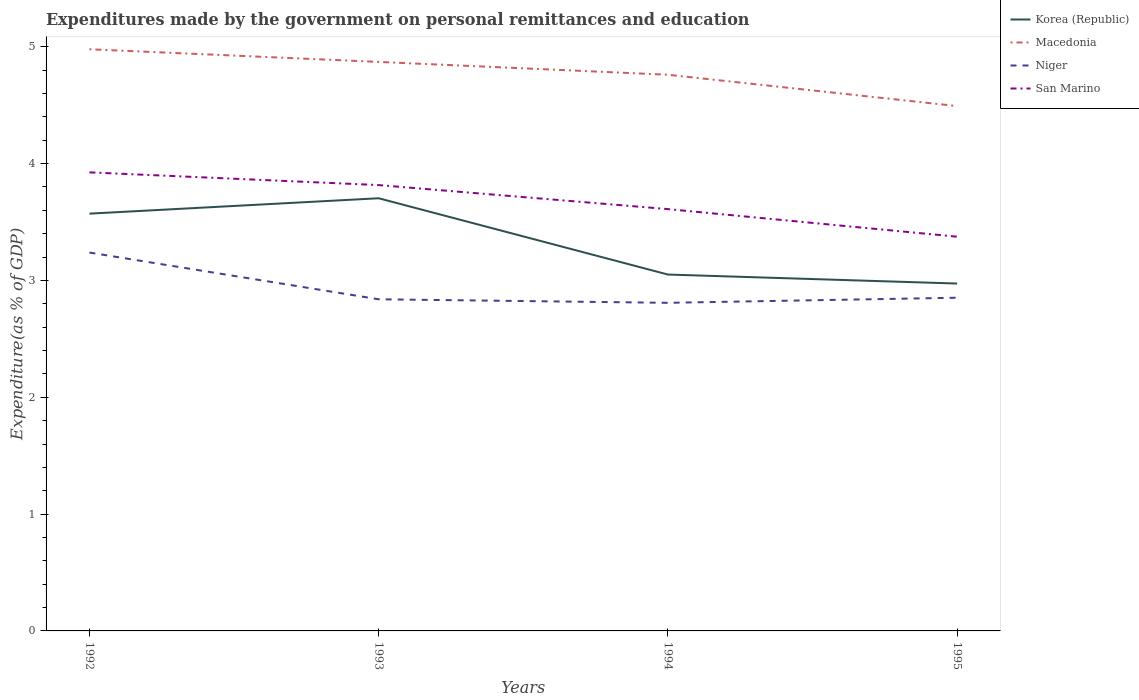Does the line corresponding to Niger intersect with the line corresponding to Macedonia?
Provide a succinct answer. No. Across all years, what is the maximum expenditures made by the government on personal remittances and education in Macedonia?
Your answer should be compact. 4.49. What is the total expenditures made by the government on personal remittances and education in San Marino in the graph?
Your answer should be compact. 0.21. What is the difference between the highest and the second highest expenditures made by the government on personal remittances and education in Korea (Republic)?
Your answer should be compact. 0.73. What is the difference between the highest and the lowest expenditures made by the government on personal remittances and education in Niger?
Make the answer very short. 1. How many years are there in the graph?
Your answer should be very brief. 4. What is the difference between two consecutive major ticks on the Y-axis?
Your answer should be very brief. 1. Does the graph contain any zero values?
Offer a terse response. No. Does the graph contain grids?
Your answer should be very brief. No. How are the legend labels stacked?
Your answer should be compact. Vertical. What is the title of the graph?
Provide a short and direct response. Expenditures made by the government on personal remittances and education. What is the label or title of the X-axis?
Your response must be concise. Years. What is the label or title of the Y-axis?
Provide a succinct answer. Expenditure(as % of GDP). What is the Expenditure(as % of GDP) in Korea (Republic) in 1992?
Provide a succinct answer. 3.57. What is the Expenditure(as % of GDP) of Macedonia in 1992?
Offer a very short reply. 4.98. What is the Expenditure(as % of GDP) in Niger in 1992?
Keep it short and to the point. 3.24. What is the Expenditure(as % of GDP) in San Marino in 1992?
Your answer should be very brief. 3.93. What is the Expenditure(as % of GDP) in Korea (Republic) in 1993?
Offer a terse response. 3.7. What is the Expenditure(as % of GDP) of Macedonia in 1993?
Keep it short and to the point. 4.87. What is the Expenditure(as % of GDP) of Niger in 1993?
Offer a very short reply. 2.84. What is the Expenditure(as % of GDP) of San Marino in 1993?
Give a very brief answer. 3.82. What is the Expenditure(as % of GDP) in Korea (Republic) in 1994?
Ensure brevity in your answer.  3.05. What is the Expenditure(as % of GDP) of Macedonia in 1994?
Provide a short and direct response. 4.76. What is the Expenditure(as % of GDP) in Niger in 1994?
Keep it short and to the point. 2.81. What is the Expenditure(as % of GDP) in San Marino in 1994?
Provide a short and direct response. 3.61. What is the Expenditure(as % of GDP) of Korea (Republic) in 1995?
Your answer should be very brief. 2.97. What is the Expenditure(as % of GDP) of Macedonia in 1995?
Your answer should be compact. 4.49. What is the Expenditure(as % of GDP) of Niger in 1995?
Offer a terse response. 2.85. What is the Expenditure(as % of GDP) of San Marino in 1995?
Keep it short and to the point. 3.37. Across all years, what is the maximum Expenditure(as % of GDP) in Korea (Republic)?
Your answer should be compact. 3.7. Across all years, what is the maximum Expenditure(as % of GDP) in Macedonia?
Keep it short and to the point. 4.98. Across all years, what is the maximum Expenditure(as % of GDP) in Niger?
Your answer should be compact. 3.24. Across all years, what is the maximum Expenditure(as % of GDP) of San Marino?
Give a very brief answer. 3.93. Across all years, what is the minimum Expenditure(as % of GDP) in Korea (Republic)?
Ensure brevity in your answer.  2.97. Across all years, what is the minimum Expenditure(as % of GDP) in Macedonia?
Provide a succinct answer. 4.49. Across all years, what is the minimum Expenditure(as % of GDP) of Niger?
Your response must be concise. 2.81. Across all years, what is the minimum Expenditure(as % of GDP) in San Marino?
Keep it short and to the point. 3.37. What is the total Expenditure(as % of GDP) of Korea (Republic) in the graph?
Your answer should be very brief. 13.3. What is the total Expenditure(as % of GDP) in Macedonia in the graph?
Ensure brevity in your answer.  19.1. What is the total Expenditure(as % of GDP) in Niger in the graph?
Your answer should be compact. 11.74. What is the total Expenditure(as % of GDP) in San Marino in the graph?
Give a very brief answer. 14.73. What is the difference between the Expenditure(as % of GDP) in Korea (Republic) in 1992 and that in 1993?
Offer a very short reply. -0.13. What is the difference between the Expenditure(as % of GDP) of Macedonia in 1992 and that in 1993?
Make the answer very short. 0.11. What is the difference between the Expenditure(as % of GDP) in San Marino in 1992 and that in 1993?
Give a very brief answer. 0.11. What is the difference between the Expenditure(as % of GDP) of Korea (Republic) in 1992 and that in 1994?
Make the answer very short. 0.52. What is the difference between the Expenditure(as % of GDP) of Macedonia in 1992 and that in 1994?
Provide a succinct answer. 0.22. What is the difference between the Expenditure(as % of GDP) in Niger in 1992 and that in 1994?
Offer a very short reply. 0.43. What is the difference between the Expenditure(as % of GDP) in San Marino in 1992 and that in 1994?
Give a very brief answer. 0.31. What is the difference between the Expenditure(as % of GDP) of Korea (Republic) in 1992 and that in 1995?
Your answer should be compact. 0.6. What is the difference between the Expenditure(as % of GDP) of Macedonia in 1992 and that in 1995?
Offer a very short reply. 0.49. What is the difference between the Expenditure(as % of GDP) of Niger in 1992 and that in 1995?
Provide a short and direct response. 0.39. What is the difference between the Expenditure(as % of GDP) of San Marino in 1992 and that in 1995?
Make the answer very short. 0.55. What is the difference between the Expenditure(as % of GDP) of Korea (Republic) in 1993 and that in 1994?
Ensure brevity in your answer.  0.65. What is the difference between the Expenditure(as % of GDP) of Macedonia in 1993 and that in 1994?
Keep it short and to the point. 0.11. What is the difference between the Expenditure(as % of GDP) in Niger in 1993 and that in 1994?
Your answer should be very brief. 0.03. What is the difference between the Expenditure(as % of GDP) in San Marino in 1993 and that in 1994?
Your answer should be very brief. 0.21. What is the difference between the Expenditure(as % of GDP) of Korea (Republic) in 1993 and that in 1995?
Your answer should be very brief. 0.73. What is the difference between the Expenditure(as % of GDP) in Macedonia in 1993 and that in 1995?
Your answer should be compact. 0.38. What is the difference between the Expenditure(as % of GDP) in Niger in 1993 and that in 1995?
Offer a very short reply. -0.01. What is the difference between the Expenditure(as % of GDP) of San Marino in 1993 and that in 1995?
Offer a terse response. 0.44. What is the difference between the Expenditure(as % of GDP) in Korea (Republic) in 1994 and that in 1995?
Make the answer very short. 0.08. What is the difference between the Expenditure(as % of GDP) in Macedonia in 1994 and that in 1995?
Your response must be concise. 0.27. What is the difference between the Expenditure(as % of GDP) in Niger in 1994 and that in 1995?
Provide a short and direct response. -0.04. What is the difference between the Expenditure(as % of GDP) in San Marino in 1994 and that in 1995?
Offer a terse response. 0.24. What is the difference between the Expenditure(as % of GDP) of Korea (Republic) in 1992 and the Expenditure(as % of GDP) of Macedonia in 1993?
Provide a succinct answer. -1.3. What is the difference between the Expenditure(as % of GDP) of Korea (Republic) in 1992 and the Expenditure(as % of GDP) of Niger in 1993?
Provide a short and direct response. 0.73. What is the difference between the Expenditure(as % of GDP) in Korea (Republic) in 1992 and the Expenditure(as % of GDP) in San Marino in 1993?
Give a very brief answer. -0.24. What is the difference between the Expenditure(as % of GDP) in Macedonia in 1992 and the Expenditure(as % of GDP) in Niger in 1993?
Make the answer very short. 2.14. What is the difference between the Expenditure(as % of GDP) of Macedonia in 1992 and the Expenditure(as % of GDP) of San Marino in 1993?
Offer a very short reply. 1.16. What is the difference between the Expenditure(as % of GDP) of Niger in 1992 and the Expenditure(as % of GDP) of San Marino in 1993?
Your answer should be compact. -0.58. What is the difference between the Expenditure(as % of GDP) of Korea (Republic) in 1992 and the Expenditure(as % of GDP) of Macedonia in 1994?
Offer a terse response. -1.19. What is the difference between the Expenditure(as % of GDP) of Korea (Republic) in 1992 and the Expenditure(as % of GDP) of Niger in 1994?
Offer a terse response. 0.76. What is the difference between the Expenditure(as % of GDP) in Korea (Republic) in 1992 and the Expenditure(as % of GDP) in San Marino in 1994?
Ensure brevity in your answer.  -0.04. What is the difference between the Expenditure(as % of GDP) in Macedonia in 1992 and the Expenditure(as % of GDP) in Niger in 1994?
Your answer should be compact. 2.17. What is the difference between the Expenditure(as % of GDP) of Macedonia in 1992 and the Expenditure(as % of GDP) of San Marino in 1994?
Provide a succinct answer. 1.37. What is the difference between the Expenditure(as % of GDP) in Niger in 1992 and the Expenditure(as % of GDP) in San Marino in 1994?
Give a very brief answer. -0.37. What is the difference between the Expenditure(as % of GDP) of Korea (Republic) in 1992 and the Expenditure(as % of GDP) of Macedonia in 1995?
Keep it short and to the point. -0.92. What is the difference between the Expenditure(as % of GDP) of Korea (Republic) in 1992 and the Expenditure(as % of GDP) of Niger in 1995?
Your response must be concise. 0.72. What is the difference between the Expenditure(as % of GDP) of Korea (Republic) in 1992 and the Expenditure(as % of GDP) of San Marino in 1995?
Keep it short and to the point. 0.2. What is the difference between the Expenditure(as % of GDP) in Macedonia in 1992 and the Expenditure(as % of GDP) in Niger in 1995?
Your answer should be compact. 2.13. What is the difference between the Expenditure(as % of GDP) of Macedonia in 1992 and the Expenditure(as % of GDP) of San Marino in 1995?
Offer a very short reply. 1.6. What is the difference between the Expenditure(as % of GDP) of Niger in 1992 and the Expenditure(as % of GDP) of San Marino in 1995?
Your answer should be compact. -0.14. What is the difference between the Expenditure(as % of GDP) in Korea (Republic) in 1993 and the Expenditure(as % of GDP) in Macedonia in 1994?
Your response must be concise. -1.06. What is the difference between the Expenditure(as % of GDP) in Korea (Republic) in 1993 and the Expenditure(as % of GDP) in Niger in 1994?
Offer a very short reply. 0.9. What is the difference between the Expenditure(as % of GDP) of Korea (Republic) in 1993 and the Expenditure(as % of GDP) of San Marino in 1994?
Offer a terse response. 0.09. What is the difference between the Expenditure(as % of GDP) of Macedonia in 1993 and the Expenditure(as % of GDP) of Niger in 1994?
Ensure brevity in your answer.  2.06. What is the difference between the Expenditure(as % of GDP) of Macedonia in 1993 and the Expenditure(as % of GDP) of San Marino in 1994?
Your response must be concise. 1.26. What is the difference between the Expenditure(as % of GDP) of Niger in 1993 and the Expenditure(as % of GDP) of San Marino in 1994?
Keep it short and to the point. -0.77. What is the difference between the Expenditure(as % of GDP) of Korea (Republic) in 1993 and the Expenditure(as % of GDP) of Macedonia in 1995?
Your response must be concise. -0.79. What is the difference between the Expenditure(as % of GDP) of Korea (Republic) in 1993 and the Expenditure(as % of GDP) of Niger in 1995?
Your answer should be compact. 0.85. What is the difference between the Expenditure(as % of GDP) of Korea (Republic) in 1993 and the Expenditure(as % of GDP) of San Marino in 1995?
Provide a succinct answer. 0.33. What is the difference between the Expenditure(as % of GDP) in Macedonia in 1993 and the Expenditure(as % of GDP) in Niger in 1995?
Provide a succinct answer. 2.02. What is the difference between the Expenditure(as % of GDP) of Macedonia in 1993 and the Expenditure(as % of GDP) of San Marino in 1995?
Provide a succinct answer. 1.5. What is the difference between the Expenditure(as % of GDP) in Niger in 1993 and the Expenditure(as % of GDP) in San Marino in 1995?
Provide a short and direct response. -0.54. What is the difference between the Expenditure(as % of GDP) of Korea (Republic) in 1994 and the Expenditure(as % of GDP) of Macedonia in 1995?
Ensure brevity in your answer.  -1.44. What is the difference between the Expenditure(as % of GDP) of Korea (Republic) in 1994 and the Expenditure(as % of GDP) of Niger in 1995?
Provide a short and direct response. 0.2. What is the difference between the Expenditure(as % of GDP) in Korea (Republic) in 1994 and the Expenditure(as % of GDP) in San Marino in 1995?
Offer a very short reply. -0.32. What is the difference between the Expenditure(as % of GDP) in Macedonia in 1994 and the Expenditure(as % of GDP) in Niger in 1995?
Offer a terse response. 1.91. What is the difference between the Expenditure(as % of GDP) of Macedonia in 1994 and the Expenditure(as % of GDP) of San Marino in 1995?
Your response must be concise. 1.39. What is the difference between the Expenditure(as % of GDP) in Niger in 1994 and the Expenditure(as % of GDP) in San Marino in 1995?
Your answer should be compact. -0.57. What is the average Expenditure(as % of GDP) of Korea (Republic) per year?
Ensure brevity in your answer.  3.32. What is the average Expenditure(as % of GDP) of Macedonia per year?
Ensure brevity in your answer.  4.78. What is the average Expenditure(as % of GDP) in Niger per year?
Give a very brief answer. 2.93. What is the average Expenditure(as % of GDP) in San Marino per year?
Your answer should be very brief. 3.68. In the year 1992, what is the difference between the Expenditure(as % of GDP) in Korea (Republic) and Expenditure(as % of GDP) in Macedonia?
Your response must be concise. -1.41. In the year 1992, what is the difference between the Expenditure(as % of GDP) in Korea (Republic) and Expenditure(as % of GDP) in Niger?
Your answer should be compact. 0.33. In the year 1992, what is the difference between the Expenditure(as % of GDP) in Korea (Republic) and Expenditure(as % of GDP) in San Marino?
Your response must be concise. -0.35. In the year 1992, what is the difference between the Expenditure(as % of GDP) in Macedonia and Expenditure(as % of GDP) in Niger?
Keep it short and to the point. 1.74. In the year 1992, what is the difference between the Expenditure(as % of GDP) in Macedonia and Expenditure(as % of GDP) in San Marino?
Your response must be concise. 1.05. In the year 1992, what is the difference between the Expenditure(as % of GDP) in Niger and Expenditure(as % of GDP) in San Marino?
Your answer should be very brief. -0.69. In the year 1993, what is the difference between the Expenditure(as % of GDP) of Korea (Republic) and Expenditure(as % of GDP) of Macedonia?
Make the answer very short. -1.17. In the year 1993, what is the difference between the Expenditure(as % of GDP) in Korea (Republic) and Expenditure(as % of GDP) in Niger?
Give a very brief answer. 0.86. In the year 1993, what is the difference between the Expenditure(as % of GDP) of Korea (Republic) and Expenditure(as % of GDP) of San Marino?
Make the answer very short. -0.11. In the year 1993, what is the difference between the Expenditure(as % of GDP) of Macedonia and Expenditure(as % of GDP) of Niger?
Ensure brevity in your answer.  2.03. In the year 1993, what is the difference between the Expenditure(as % of GDP) in Macedonia and Expenditure(as % of GDP) in San Marino?
Keep it short and to the point. 1.05. In the year 1993, what is the difference between the Expenditure(as % of GDP) in Niger and Expenditure(as % of GDP) in San Marino?
Your answer should be compact. -0.98. In the year 1994, what is the difference between the Expenditure(as % of GDP) of Korea (Republic) and Expenditure(as % of GDP) of Macedonia?
Your response must be concise. -1.71. In the year 1994, what is the difference between the Expenditure(as % of GDP) in Korea (Republic) and Expenditure(as % of GDP) in Niger?
Your answer should be very brief. 0.24. In the year 1994, what is the difference between the Expenditure(as % of GDP) in Korea (Republic) and Expenditure(as % of GDP) in San Marino?
Make the answer very short. -0.56. In the year 1994, what is the difference between the Expenditure(as % of GDP) of Macedonia and Expenditure(as % of GDP) of Niger?
Offer a terse response. 1.95. In the year 1994, what is the difference between the Expenditure(as % of GDP) in Macedonia and Expenditure(as % of GDP) in San Marino?
Keep it short and to the point. 1.15. In the year 1994, what is the difference between the Expenditure(as % of GDP) of Niger and Expenditure(as % of GDP) of San Marino?
Your answer should be compact. -0.8. In the year 1995, what is the difference between the Expenditure(as % of GDP) in Korea (Republic) and Expenditure(as % of GDP) in Macedonia?
Provide a short and direct response. -1.52. In the year 1995, what is the difference between the Expenditure(as % of GDP) of Korea (Republic) and Expenditure(as % of GDP) of Niger?
Your answer should be compact. 0.12. In the year 1995, what is the difference between the Expenditure(as % of GDP) in Korea (Republic) and Expenditure(as % of GDP) in San Marino?
Make the answer very short. -0.4. In the year 1995, what is the difference between the Expenditure(as % of GDP) of Macedonia and Expenditure(as % of GDP) of Niger?
Keep it short and to the point. 1.64. In the year 1995, what is the difference between the Expenditure(as % of GDP) of Macedonia and Expenditure(as % of GDP) of San Marino?
Ensure brevity in your answer.  1.12. In the year 1995, what is the difference between the Expenditure(as % of GDP) of Niger and Expenditure(as % of GDP) of San Marino?
Make the answer very short. -0.52. What is the ratio of the Expenditure(as % of GDP) in Korea (Republic) in 1992 to that in 1993?
Make the answer very short. 0.96. What is the ratio of the Expenditure(as % of GDP) of Macedonia in 1992 to that in 1993?
Provide a succinct answer. 1.02. What is the ratio of the Expenditure(as % of GDP) of Niger in 1992 to that in 1993?
Provide a succinct answer. 1.14. What is the ratio of the Expenditure(as % of GDP) of San Marino in 1992 to that in 1993?
Offer a very short reply. 1.03. What is the ratio of the Expenditure(as % of GDP) of Korea (Republic) in 1992 to that in 1994?
Offer a terse response. 1.17. What is the ratio of the Expenditure(as % of GDP) of Macedonia in 1992 to that in 1994?
Offer a very short reply. 1.05. What is the ratio of the Expenditure(as % of GDP) of Niger in 1992 to that in 1994?
Your response must be concise. 1.15. What is the ratio of the Expenditure(as % of GDP) in San Marino in 1992 to that in 1994?
Ensure brevity in your answer.  1.09. What is the ratio of the Expenditure(as % of GDP) of Korea (Republic) in 1992 to that in 1995?
Your response must be concise. 1.2. What is the ratio of the Expenditure(as % of GDP) in Macedonia in 1992 to that in 1995?
Your answer should be very brief. 1.11. What is the ratio of the Expenditure(as % of GDP) in Niger in 1992 to that in 1995?
Offer a very short reply. 1.14. What is the ratio of the Expenditure(as % of GDP) of San Marino in 1992 to that in 1995?
Ensure brevity in your answer.  1.16. What is the ratio of the Expenditure(as % of GDP) of Korea (Republic) in 1993 to that in 1994?
Offer a very short reply. 1.21. What is the ratio of the Expenditure(as % of GDP) of Macedonia in 1993 to that in 1994?
Your answer should be very brief. 1.02. What is the ratio of the Expenditure(as % of GDP) of Niger in 1993 to that in 1994?
Ensure brevity in your answer.  1.01. What is the ratio of the Expenditure(as % of GDP) of San Marino in 1993 to that in 1994?
Make the answer very short. 1.06. What is the ratio of the Expenditure(as % of GDP) of Korea (Republic) in 1993 to that in 1995?
Your answer should be very brief. 1.25. What is the ratio of the Expenditure(as % of GDP) of Macedonia in 1993 to that in 1995?
Your response must be concise. 1.08. What is the ratio of the Expenditure(as % of GDP) in Niger in 1993 to that in 1995?
Your response must be concise. 1. What is the ratio of the Expenditure(as % of GDP) in San Marino in 1993 to that in 1995?
Keep it short and to the point. 1.13. What is the ratio of the Expenditure(as % of GDP) in Korea (Republic) in 1994 to that in 1995?
Your answer should be compact. 1.03. What is the ratio of the Expenditure(as % of GDP) in Macedonia in 1994 to that in 1995?
Give a very brief answer. 1.06. What is the ratio of the Expenditure(as % of GDP) of Niger in 1994 to that in 1995?
Provide a short and direct response. 0.98. What is the ratio of the Expenditure(as % of GDP) of San Marino in 1994 to that in 1995?
Provide a short and direct response. 1.07. What is the difference between the highest and the second highest Expenditure(as % of GDP) of Korea (Republic)?
Provide a succinct answer. 0.13. What is the difference between the highest and the second highest Expenditure(as % of GDP) in Macedonia?
Your answer should be compact. 0.11. What is the difference between the highest and the second highest Expenditure(as % of GDP) of Niger?
Offer a terse response. 0.39. What is the difference between the highest and the second highest Expenditure(as % of GDP) of San Marino?
Your answer should be very brief. 0.11. What is the difference between the highest and the lowest Expenditure(as % of GDP) of Korea (Republic)?
Offer a very short reply. 0.73. What is the difference between the highest and the lowest Expenditure(as % of GDP) in Macedonia?
Your answer should be very brief. 0.49. What is the difference between the highest and the lowest Expenditure(as % of GDP) in Niger?
Keep it short and to the point. 0.43. What is the difference between the highest and the lowest Expenditure(as % of GDP) of San Marino?
Provide a succinct answer. 0.55. 